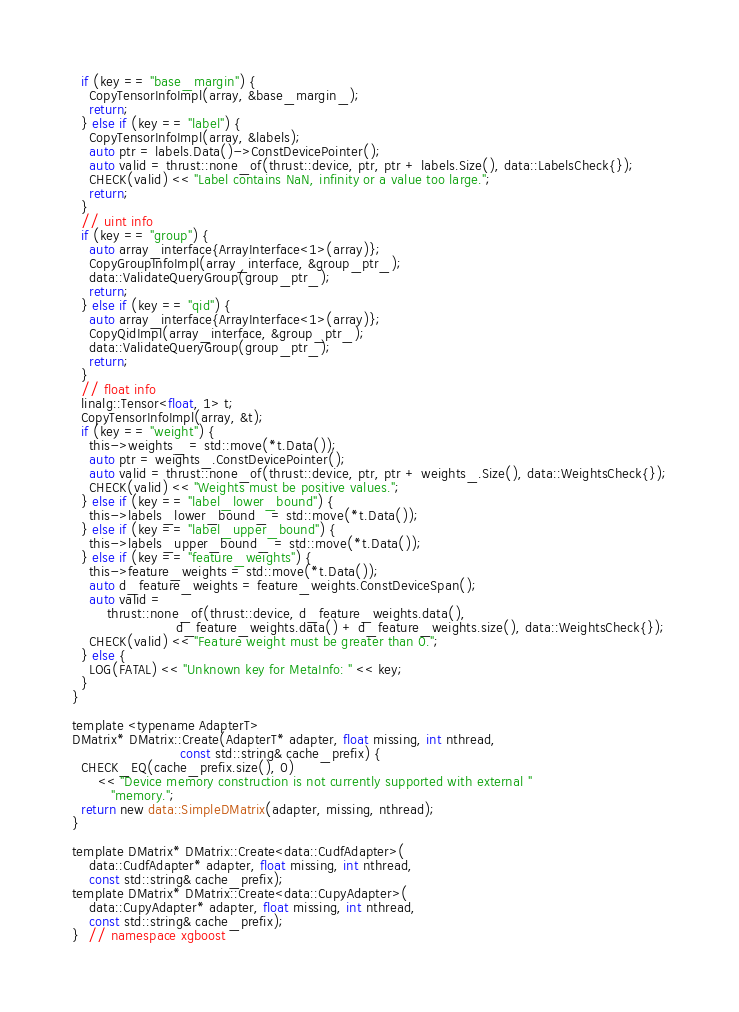<code> <loc_0><loc_0><loc_500><loc_500><_Cuda_>  if (key == "base_margin") {
    CopyTensorInfoImpl(array, &base_margin_);
    return;
  } else if (key == "label") {
    CopyTensorInfoImpl(array, &labels);
    auto ptr = labels.Data()->ConstDevicePointer();
    auto valid = thrust::none_of(thrust::device, ptr, ptr + labels.Size(), data::LabelsCheck{});
    CHECK(valid) << "Label contains NaN, infinity or a value too large.";
    return;
  }
  // uint info
  if (key == "group") {
    auto array_interface{ArrayInterface<1>(array)};
    CopyGroupInfoImpl(array_interface, &group_ptr_);
    data::ValidateQueryGroup(group_ptr_);
    return;
  } else if (key == "qid") {
    auto array_interface{ArrayInterface<1>(array)};
    CopyQidImpl(array_interface, &group_ptr_);
    data::ValidateQueryGroup(group_ptr_);
    return;
  }
  // float info
  linalg::Tensor<float, 1> t;
  CopyTensorInfoImpl(array, &t);
  if (key == "weight") {
    this->weights_ = std::move(*t.Data());
    auto ptr = weights_.ConstDevicePointer();
    auto valid = thrust::none_of(thrust::device, ptr, ptr + weights_.Size(), data::WeightsCheck{});
    CHECK(valid) << "Weights must be positive values.";
  } else if (key == "label_lower_bound") {
    this->labels_lower_bound_ = std::move(*t.Data());
  } else if (key == "label_upper_bound") {
    this->labels_upper_bound_ = std::move(*t.Data());
  } else if (key == "feature_weights") {
    this->feature_weights = std::move(*t.Data());
    auto d_feature_weights = feature_weights.ConstDeviceSpan();
    auto valid =
        thrust::none_of(thrust::device, d_feature_weights.data(),
                        d_feature_weights.data() + d_feature_weights.size(), data::WeightsCheck{});
    CHECK(valid) << "Feature weight must be greater than 0.";
  } else {
    LOG(FATAL) << "Unknown key for MetaInfo: " << key;
  }
}

template <typename AdapterT>
DMatrix* DMatrix::Create(AdapterT* adapter, float missing, int nthread,
                         const std::string& cache_prefix) {
  CHECK_EQ(cache_prefix.size(), 0)
      << "Device memory construction is not currently supported with external "
         "memory.";
  return new data::SimpleDMatrix(adapter, missing, nthread);
}

template DMatrix* DMatrix::Create<data::CudfAdapter>(
    data::CudfAdapter* adapter, float missing, int nthread,
    const std::string& cache_prefix);
template DMatrix* DMatrix::Create<data::CupyAdapter>(
    data::CupyAdapter* adapter, float missing, int nthread,
    const std::string& cache_prefix);
}  // namespace xgboost
</code> 